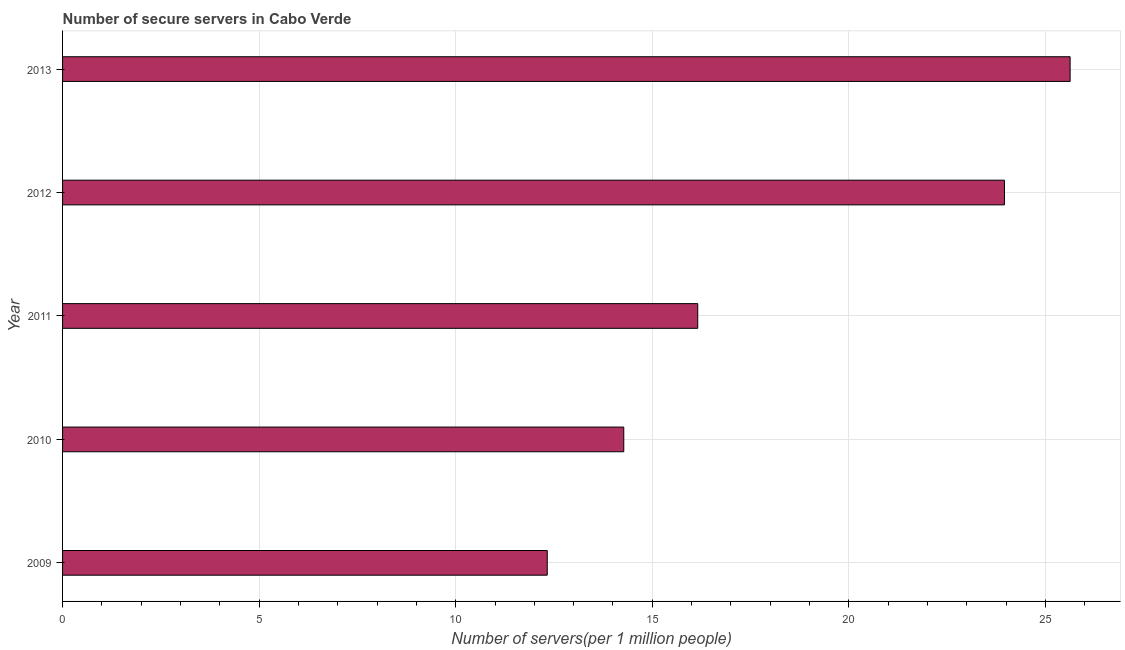Does the graph contain any zero values?
Give a very brief answer. No. What is the title of the graph?
Offer a terse response. Number of secure servers in Cabo Verde. What is the label or title of the X-axis?
Offer a very short reply. Number of servers(per 1 million people). What is the number of secure internet servers in 2013?
Make the answer very short. 25.63. Across all years, what is the maximum number of secure internet servers?
Ensure brevity in your answer.  25.63. Across all years, what is the minimum number of secure internet servers?
Offer a terse response. 12.33. What is the sum of the number of secure internet servers?
Keep it short and to the point. 92.35. What is the difference between the number of secure internet servers in 2009 and 2010?
Provide a short and direct response. -1.95. What is the average number of secure internet servers per year?
Offer a terse response. 18.47. What is the median number of secure internet servers?
Your answer should be very brief. 16.16. Do a majority of the years between 2010 and 2012 (inclusive) have number of secure internet servers greater than 9 ?
Provide a succinct answer. Yes. What is the ratio of the number of secure internet servers in 2011 to that in 2013?
Keep it short and to the point. 0.63. Is the number of secure internet servers in 2010 less than that in 2012?
Offer a very short reply. Yes. What is the difference between the highest and the second highest number of secure internet servers?
Offer a terse response. 1.67. In how many years, is the number of secure internet servers greater than the average number of secure internet servers taken over all years?
Offer a terse response. 2. How many years are there in the graph?
Give a very brief answer. 5. Are the values on the major ticks of X-axis written in scientific E-notation?
Ensure brevity in your answer.  No. What is the Number of servers(per 1 million people) in 2009?
Offer a terse response. 12.33. What is the Number of servers(per 1 million people) of 2010?
Keep it short and to the point. 14.27. What is the Number of servers(per 1 million people) of 2011?
Your response must be concise. 16.16. What is the Number of servers(per 1 million people) of 2012?
Your answer should be compact. 23.96. What is the Number of servers(per 1 million people) of 2013?
Offer a terse response. 25.63. What is the difference between the Number of servers(per 1 million people) in 2009 and 2010?
Make the answer very short. -1.95. What is the difference between the Number of servers(per 1 million people) in 2009 and 2011?
Offer a very short reply. -3.83. What is the difference between the Number of servers(per 1 million people) in 2009 and 2012?
Keep it short and to the point. -11.63. What is the difference between the Number of servers(per 1 million people) in 2009 and 2013?
Give a very brief answer. -13.3. What is the difference between the Number of servers(per 1 million people) in 2010 and 2011?
Give a very brief answer. -1.88. What is the difference between the Number of servers(per 1 million people) in 2010 and 2012?
Keep it short and to the point. -9.68. What is the difference between the Number of servers(per 1 million people) in 2010 and 2013?
Your answer should be compact. -11.35. What is the difference between the Number of servers(per 1 million people) in 2011 and 2012?
Your answer should be very brief. -7.8. What is the difference between the Number of servers(per 1 million people) in 2011 and 2013?
Your response must be concise. -9.47. What is the difference between the Number of servers(per 1 million people) in 2012 and 2013?
Keep it short and to the point. -1.67. What is the ratio of the Number of servers(per 1 million people) in 2009 to that in 2010?
Your answer should be compact. 0.86. What is the ratio of the Number of servers(per 1 million people) in 2009 to that in 2011?
Provide a short and direct response. 0.76. What is the ratio of the Number of servers(per 1 million people) in 2009 to that in 2012?
Offer a very short reply. 0.52. What is the ratio of the Number of servers(per 1 million people) in 2009 to that in 2013?
Keep it short and to the point. 0.48. What is the ratio of the Number of servers(per 1 million people) in 2010 to that in 2011?
Your answer should be compact. 0.88. What is the ratio of the Number of servers(per 1 million people) in 2010 to that in 2012?
Offer a terse response. 0.6. What is the ratio of the Number of servers(per 1 million people) in 2010 to that in 2013?
Your answer should be compact. 0.56. What is the ratio of the Number of servers(per 1 million people) in 2011 to that in 2012?
Offer a very short reply. 0.67. What is the ratio of the Number of servers(per 1 million people) in 2011 to that in 2013?
Your answer should be compact. 0.63. What is the ratio of the Number of servers(per 1 million people) in 2012 to that in 2013?
Offer a terse response. 0.94. 